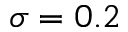<formula> <loc_0><loc_0><loc_500><loc_500>\sigma = 0 . 2</formula> 